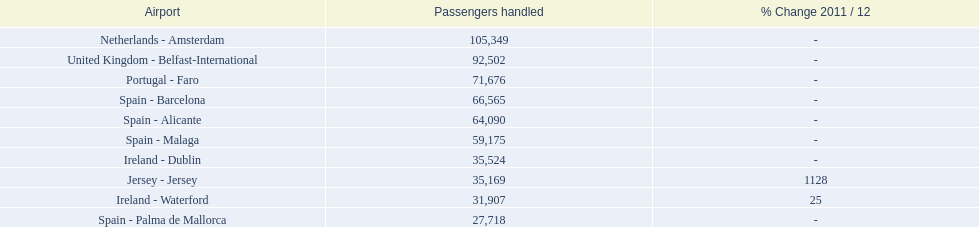Which airports are in europe? Netherlands - Amsterdam, United Kingdom - Belfast-International, Portugal - Faro, Spain - Barcelona, Spain - Alicante, Spain - Malaga, Ireland - Dublin, Ireland - Waterford, Spain - Palma de Mallorca. Which one is from portugal? Portugal - Faro. 